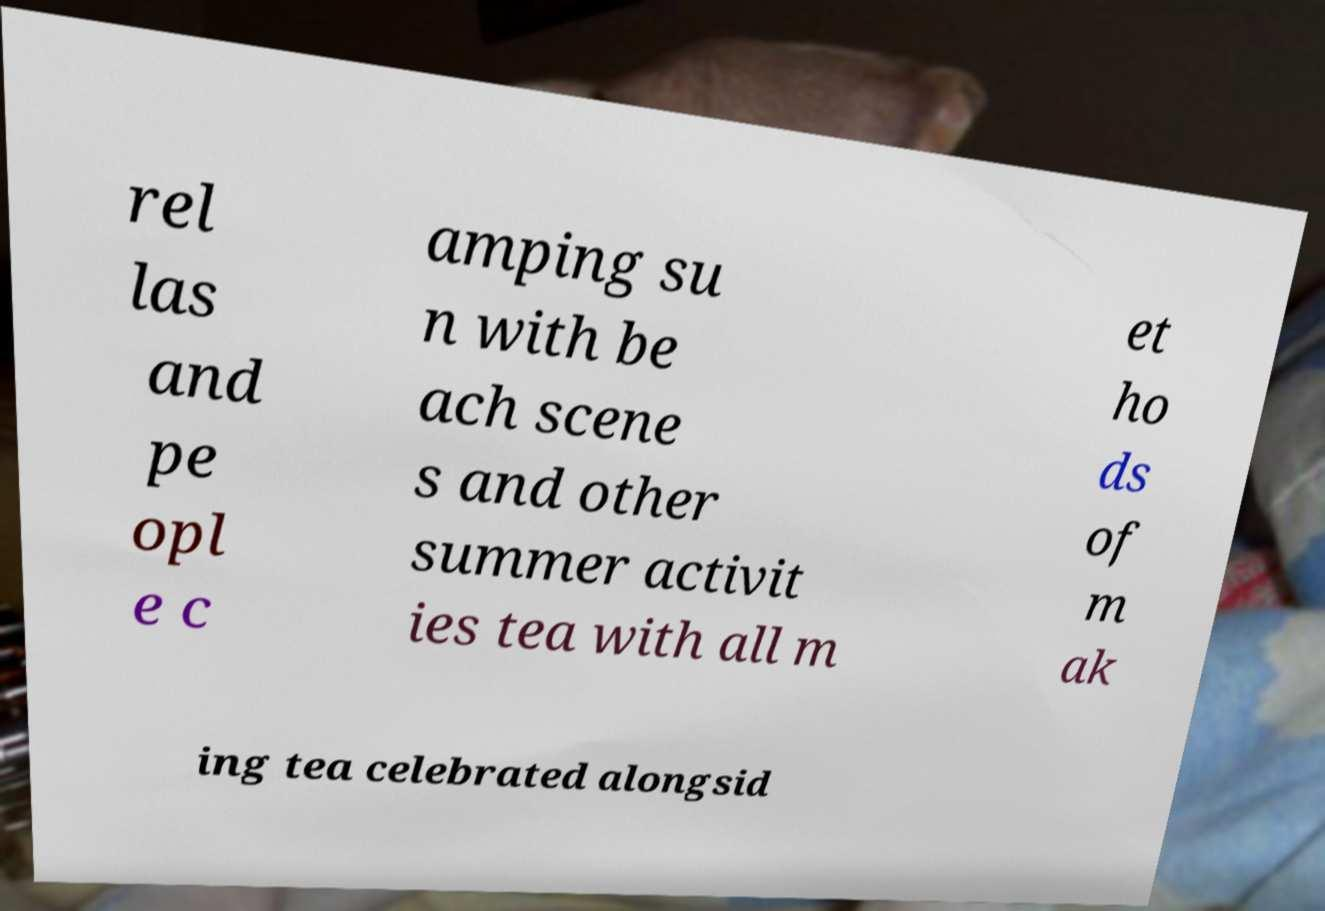For documentation purposes, I need the text within this image transcribed. Could you provide that? rel las and pe opl e c amping su n with be ach scene s and other summer activit ies tea with all m et ho ds of m ak ing tea celebrated alongsid 